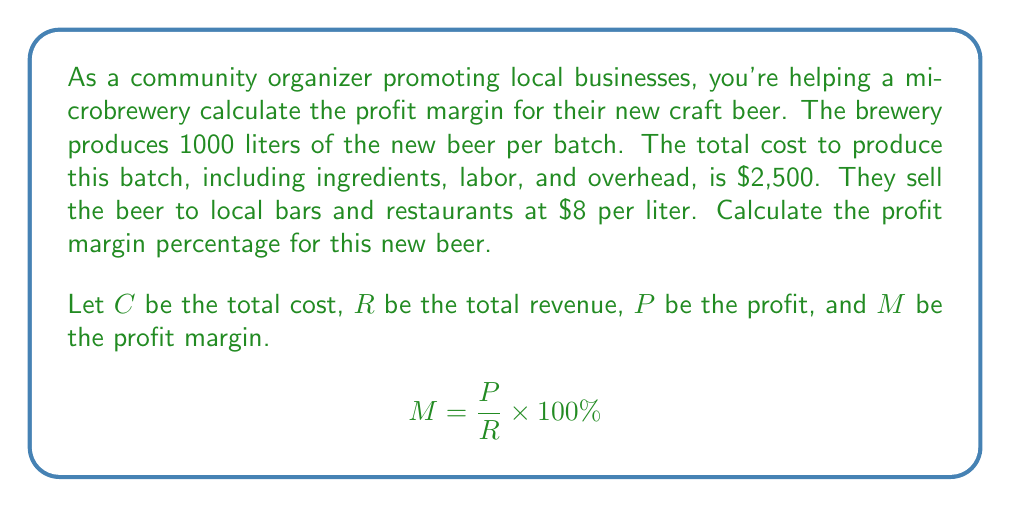Can you solve this math problem? To solve this problem, we need to follow these steps:

1. Calculate the total revenue:
   Revenue = Price per liter × Number of liters
   $$R = $8 \times 1000 = $8000$$

2. Calculate the profit:
   Profit = Revenue - Cost
   $$P = R - C = $8000 - $2500 = $5500$$

3. Calculate the profit margin:
   $$M = \frac{P}{R} \times 100\%$$
   $$M = \frac{$5500}{$8000} \times 100\%$$
   $$M = 0.6875 \times 100\% = 68.75\%$$

The profit margin is the percentage of revenue that becomes profit. In this case, 68.75% of the revenue from selling the new beer becomes profit for the microbrewery.
Answer: The profit margin for the microbrewery's new beer is 68.75%. 